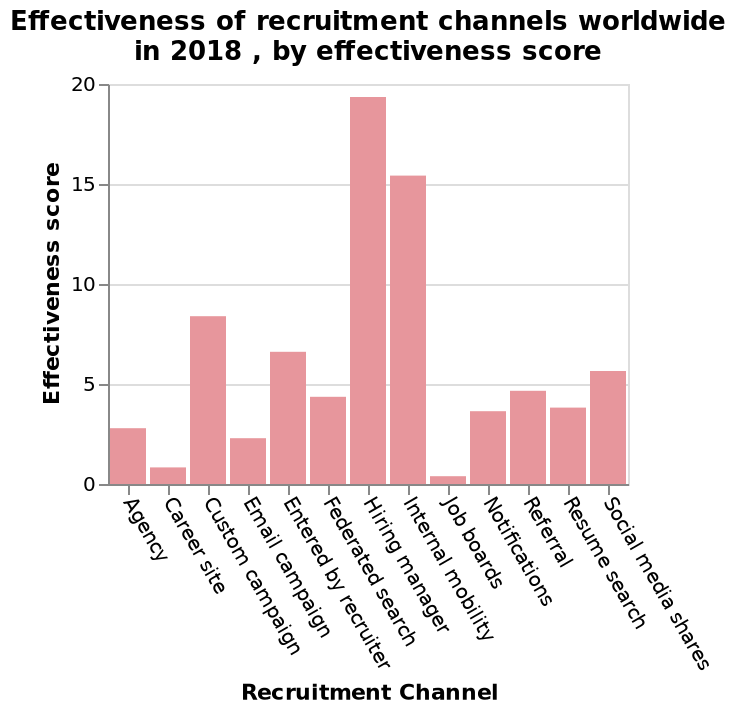<image>
What does the x-axis of the bar graph represent? The x-axis of the bar graph represents the Recruitment Channel. Describe the following image in detail Effectiveness of recruitment channels worldwide in 2018 , by effectiveness score is a bar graph. The x-axis shows Recruitment Channel. On the y-axis, Effectiveness score is defined. According to the figure, which recruitment channels are recommended for the best results? Based on the figure, it is recommended to use hiring manager and internal mobility recruitment channels for better recruitment outcomes. What year does the bar graph represent? The bar graph represents the year 2018. How are career sites and job boards scored for their effectiveness in recruitment? Career sites and job boards are scored as very ineffective channels for recruitment. 